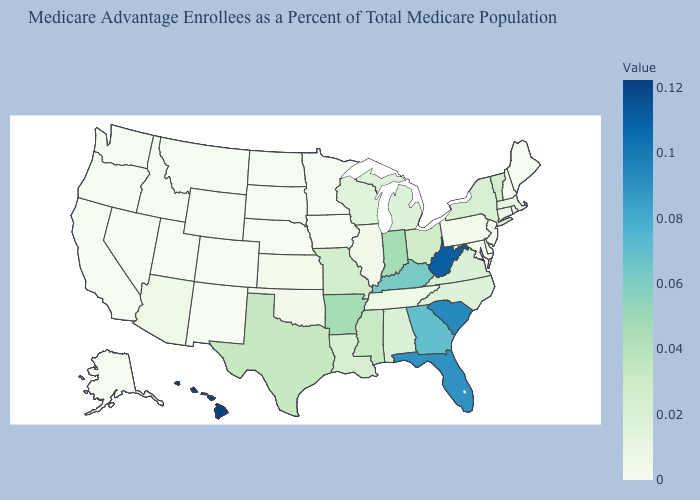Does Missouri have the lowest value in the MidWest?
Keep it brief. No. Which states have the highest value in the USA?
Give a very brief answer. Hawaii. Is the legend a continuous bar?
Be succinct. Yes. Among the states that border New Mexico , which have the highest value?
Give a very brief answer. Texas. Is the legend a continuous bar?
Short answer required. Yes. Among the states that border New Mexico , which have the lowest value?
Answer briefly. Colorado, Utah. 